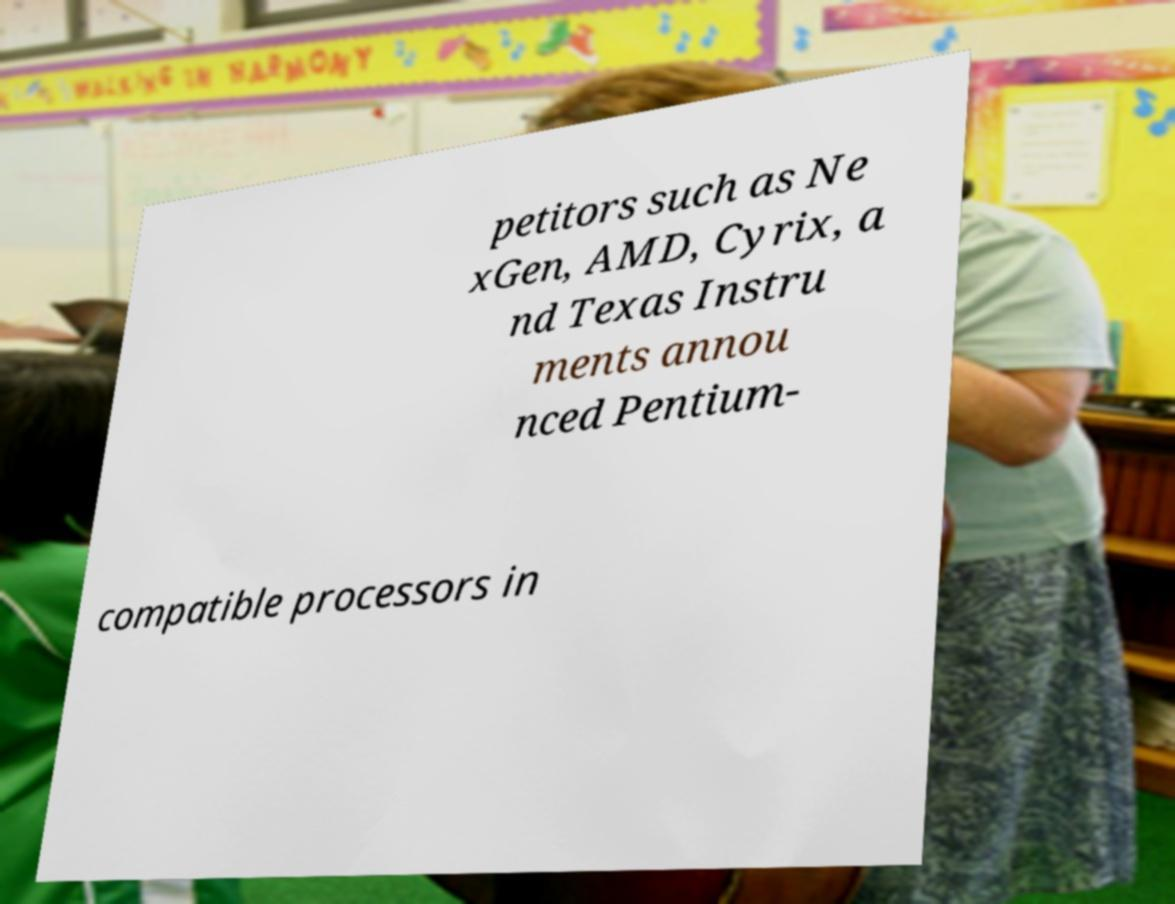Could you extract and type out the text from this image? petitors such as Ne xGen, AMD, Cyrix, a nd Texas Instru ments annou nced Pentium- compatible processors in 